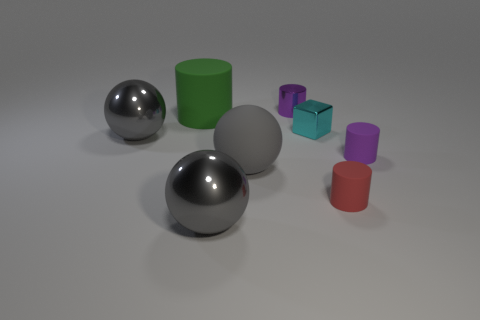Subtract 1 cylinders. How many cylinders are left? 3 Add 1 small red rubber things. How many objects exist? 9 Subtract all yellow spheres. Subtract all red cylinders. How many spheres are left? 3 Subtract all blocks. How many objects are left? 7 Subtract 3 gray spheres. How many objects are left? 5 Subtract all tiny red objects. Subtract all gray metallic things. How many objects are left? 5 Add 6 large gray rubber balls. How many large gray rubber balls are left? 7 Add 4 tiny green spheres. How many tiny green spheres exist? 4 